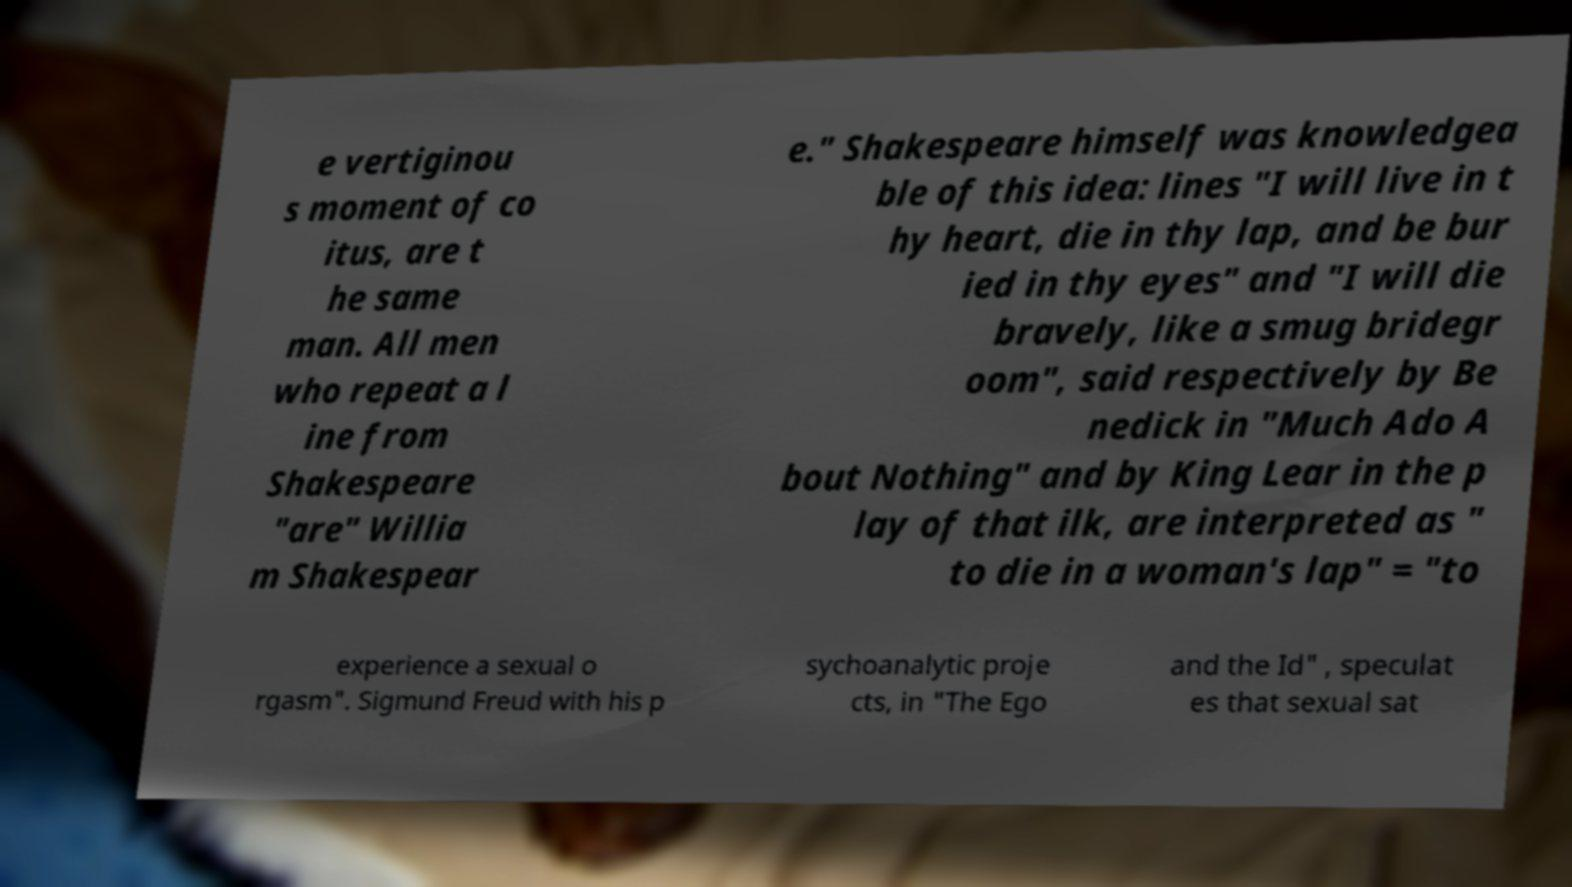For documentation purposes, I need the text within this image transcribed. Could you provide that? e vertiginou s moment of co itus, are t he same man. All men who repeat a l ine from Shakespeare "are" Willia m Shakespear e." Shakespeare himself was knowledgea ble of this idea: lines "I will live in t hy heart, die in thy lap, and be bur ied in thy eyes" and "I will die bravely, like a smug bridegr oom", said respectively by Be nedick in "Much Ado A bout Nothing" and by King Lear in the p lay of that ilk, are interpreted as " to die in a woman's lap" = "to experience a sexual o rgasm". Sigmund Freud with his p sychoanalytic proje cts, in "The Ego and the Id" , speculat es that sexual sat 